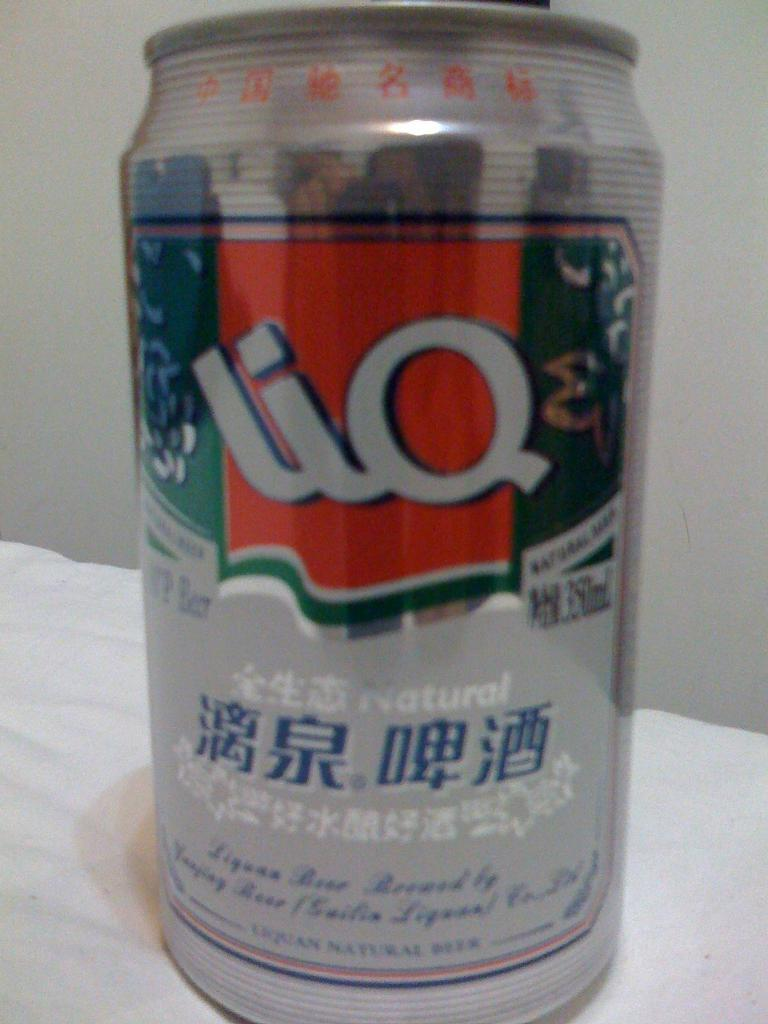<image>
Describe the image concisely. A can of beer has the word "natural" on the label. 